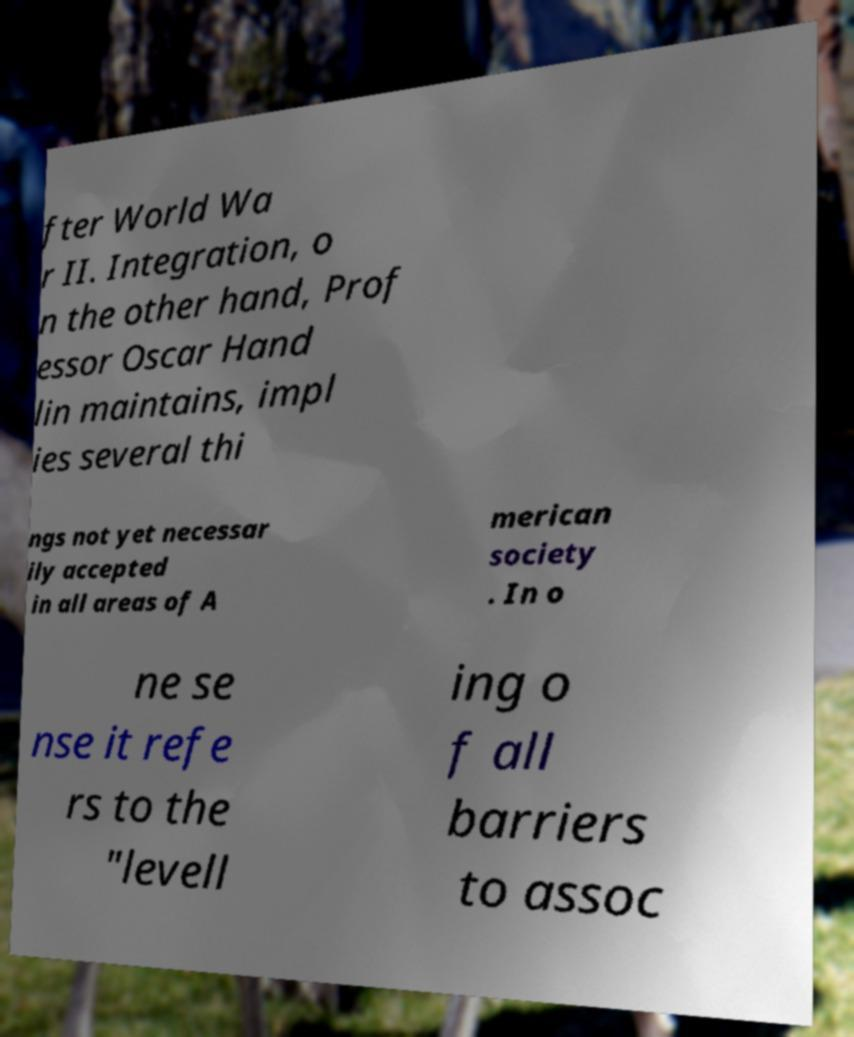Can you read and provide the text displayed in the image?This photo seems to have some interesting text. Can you extract and type it out for me? fter World Wa r II. Integration, o n the other hand, Prof essor Oscar Hand lin maintains, impl ies several thi ngs not yet necessar ily accepted in all areas of A merican society . In o ne se nse it refe rs to the "levell ing o f all barriers to assoc 